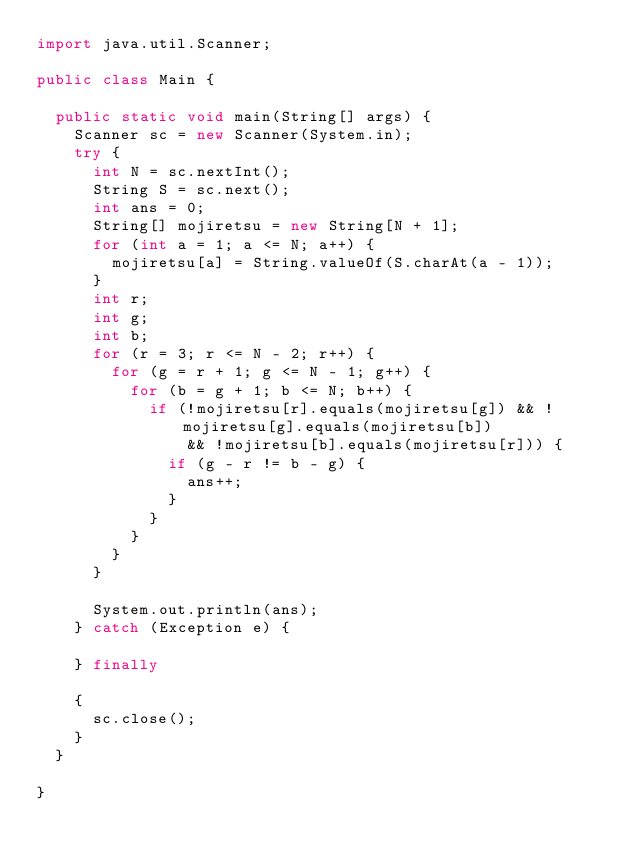<code> <loc_0><loc_0><loc_500><loc_500><_Java_>import java.util.Scanner;

public class Main {

	public static void main(String[] args) {
		Scanner sc = new Scanner(System.in);
		try {
			int N = sc.nextInt();
			String S = sc.next();
			int ans = 0;
			String[] mojiretsu = new String[N + 1];
			for (int a = 1; a <= N; a++) {
				mojiretsu[a] = String.valueOf(S.charAt(a - 1));
			}
			int r;
			int g;
			int b;
			for (r = 3; r <= N - 2; r++) {
				for (g = r + 1; g <= N - 1; g++) {
					for (b = g + 1; b <= N; b++) {
						if (!mojiretsu[r].equals(mojiretsu[g]) && !mojiretsu[g].equals(mojiretsu[b])
								&& !mojiretsu[b].equals(mojiretsu[r])) {
							if (g - r != b - g) {
								ans++;
							}
						}
					}
				}
			}

			System.out.println(ans);
		} catch (Exception e) {

		} finally

		{
			sc.close();
		}
	}

}
</code> 